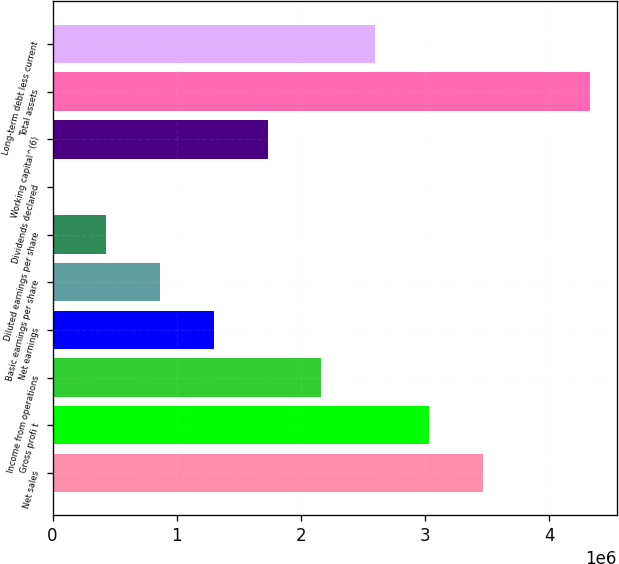<chart> <loc_0><loc_0><loc_500><loc_500><bar_chart><fcel>Net sales<fcel>Gross profi t<fcel>Income from operations<fcel>Net earnings<fcel>Basic earnings per share<fcel>Diluted earnings per share<fcel>Dividends declared<fcel>Working capital^(6)<fcel>Total assets<fcel>Long-term debt less current<nl><fcel>3.46219e+06<fcel>3.02942e+06<fcel>2.16387e+06<fcel>1.29832e+06<fcel>865547<fcel>432774<fcel>0.34<fcel>1.73109e+06<fcel>4.32774e+06<fcel>2.59664e+06<nl></chart> 